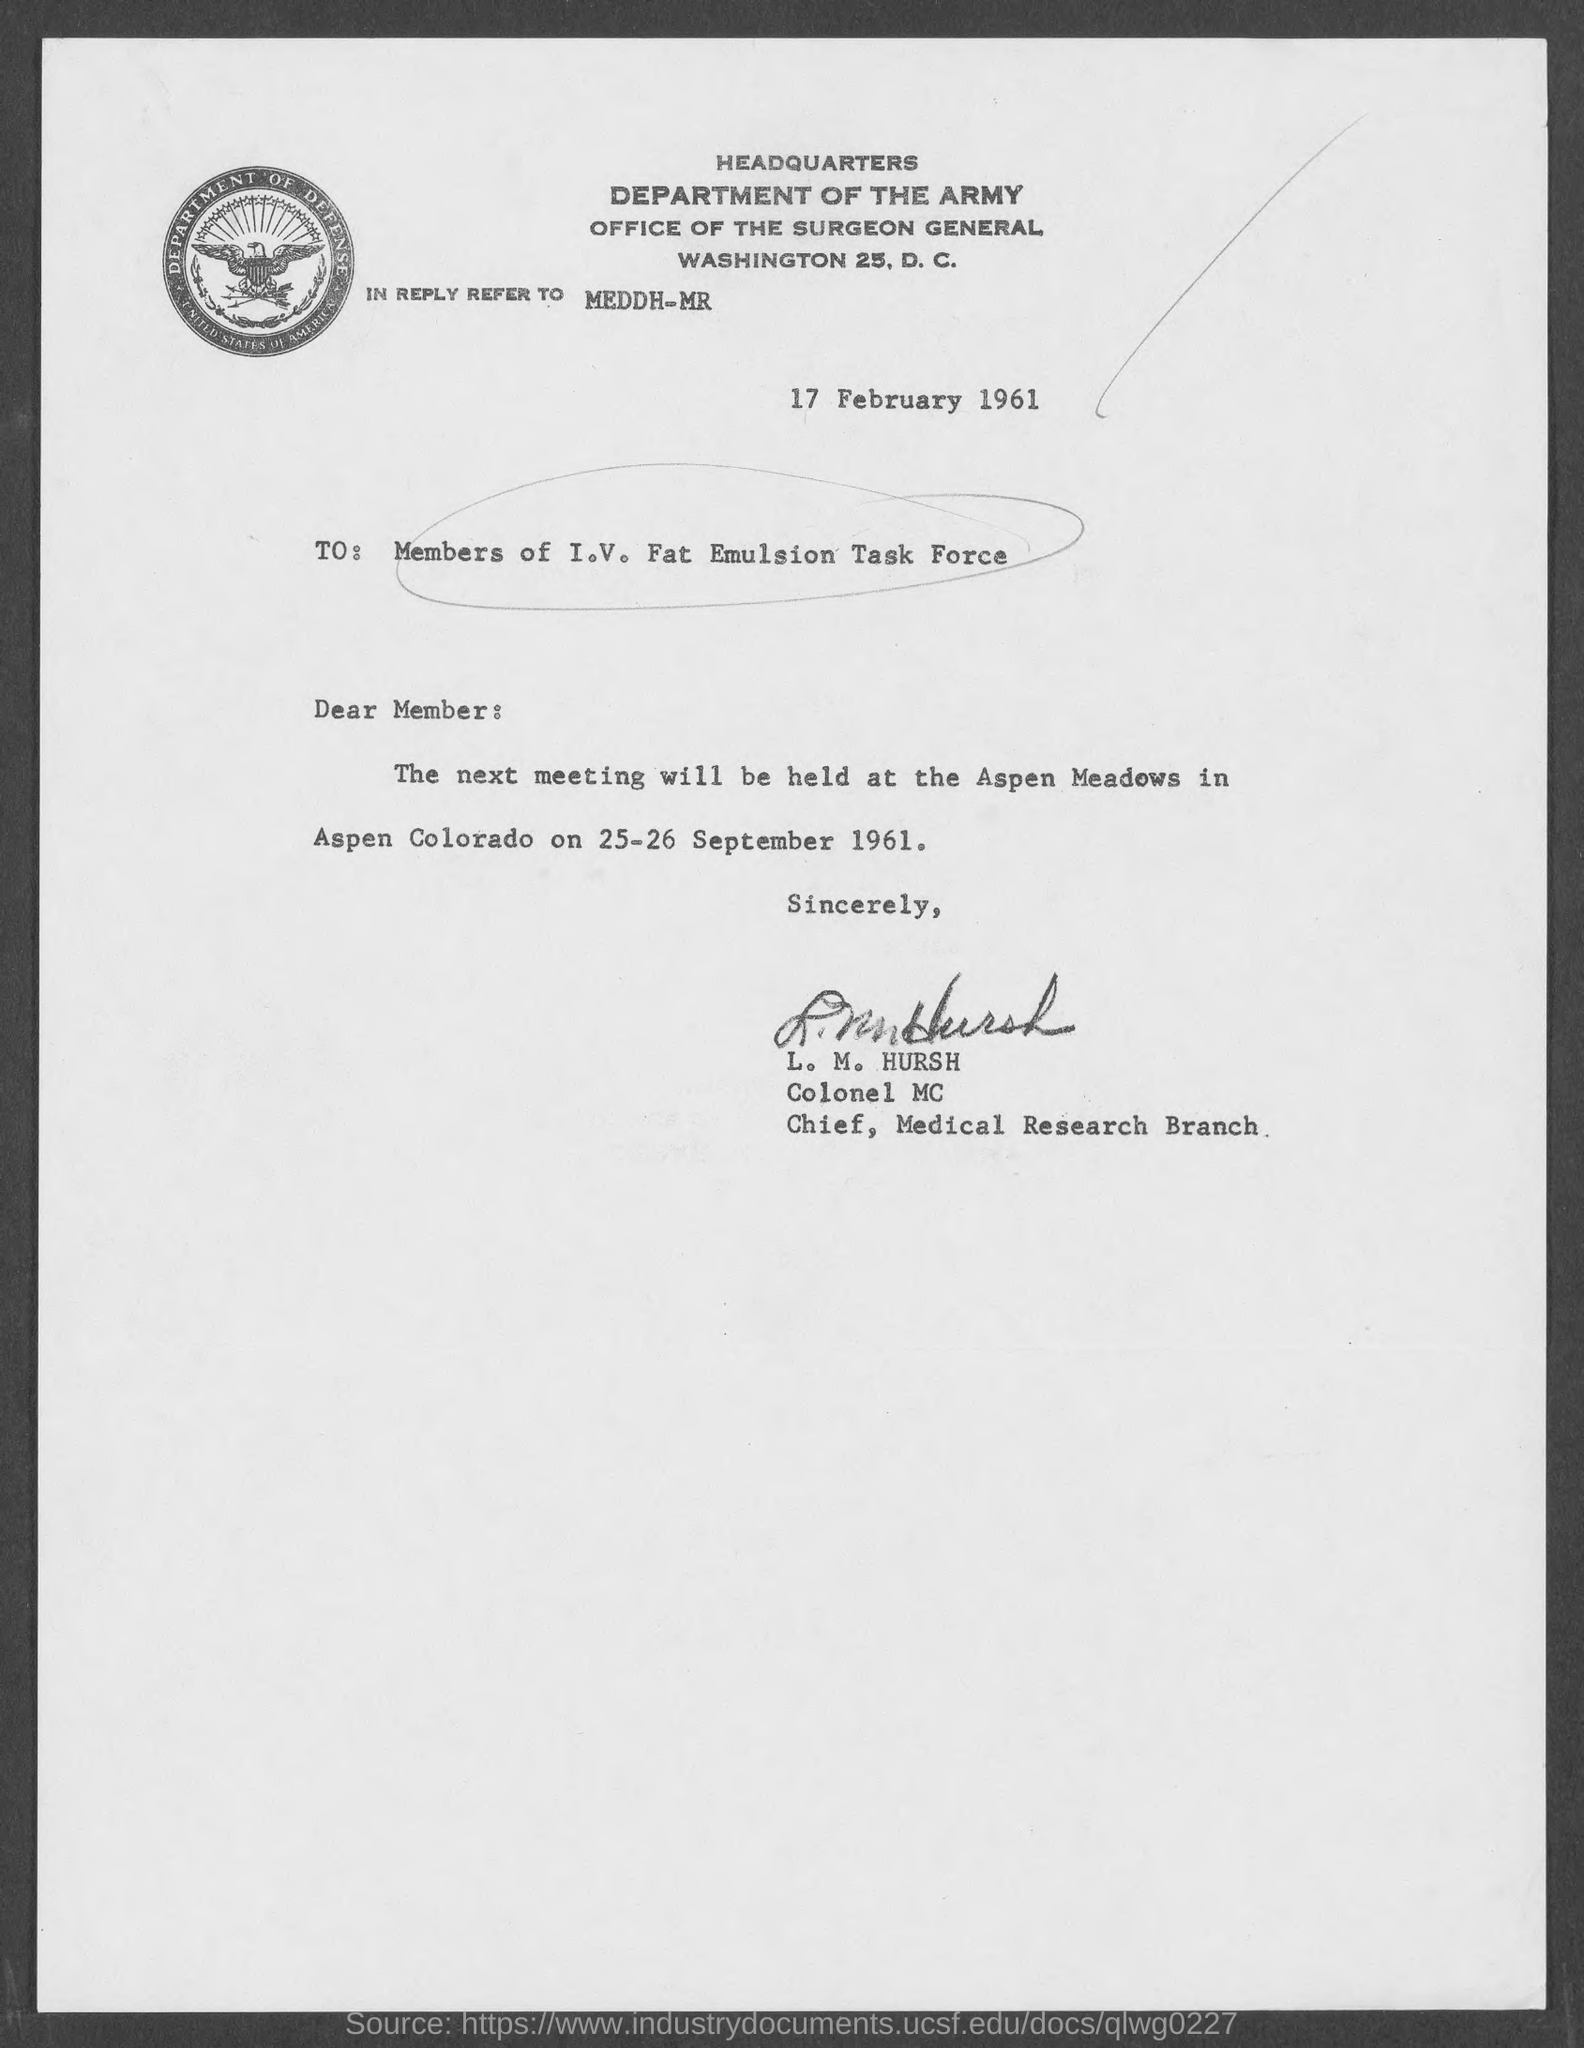Outline some significant characteristics in this image. The document indicates that the date mentioned at the top of the document is February 17, 1961. The memorandum is addressed to the members of the I.V. Fat Emulsion Task Force. 